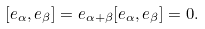Convert formula to latex. <formula><loc_0><loc_0><loc_500><loc_500>[ e _ { \alpha } , e _ { \beta } ] = e _ { \alpha + \beta } [ e _ { \alpha } , e _ { \beta } ] = 0 .</formula> 